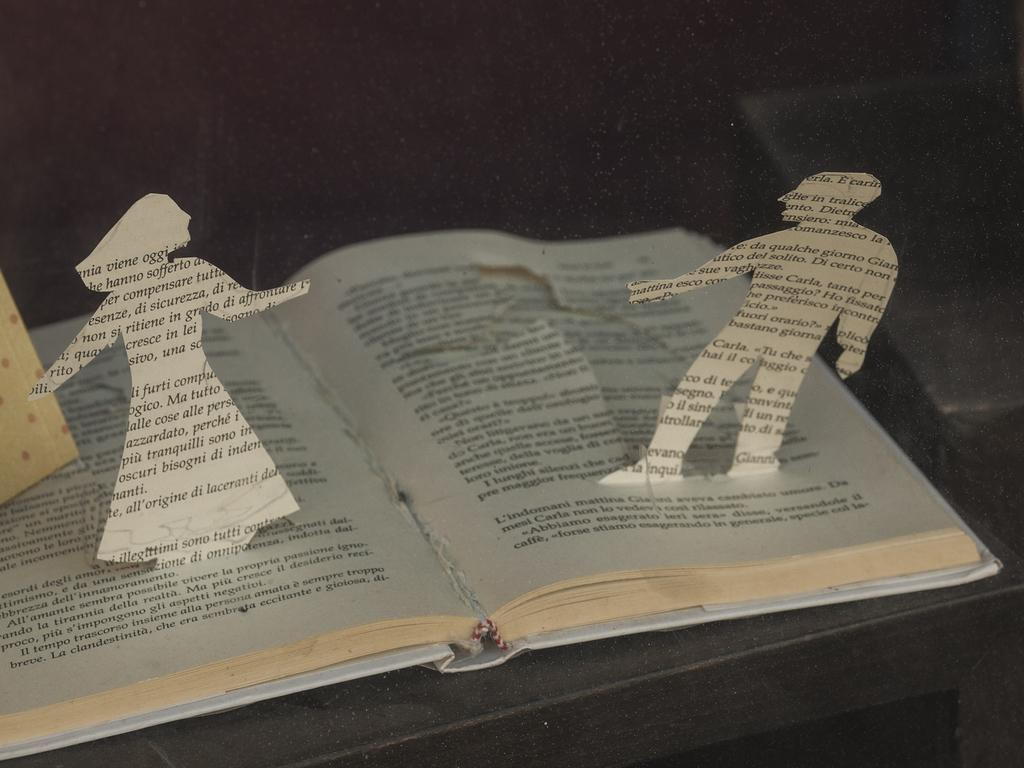<image>
Create a compact narrative representing the image presented. A cutout of a book made to look like a man and a woman with the man having the work Carla on him. 